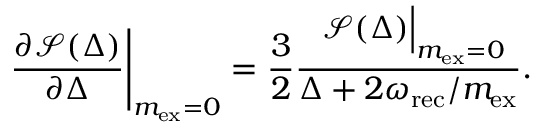<formula> <loc_0><loc_0><loc_500><loc_500>\frac { \partial \mathcal { S } ( \Delta ) } { \partial \Delta } \left | _ { m _ { e x } = 0 } = \frac { 3 } { 2 } \frac { \ \mathcal { S } ( \Delta ) \right | _ { m _ { e x } = 0 } } { \Delta + 2 \omega _ { r e c } / m _ { e x } } .</formula> 